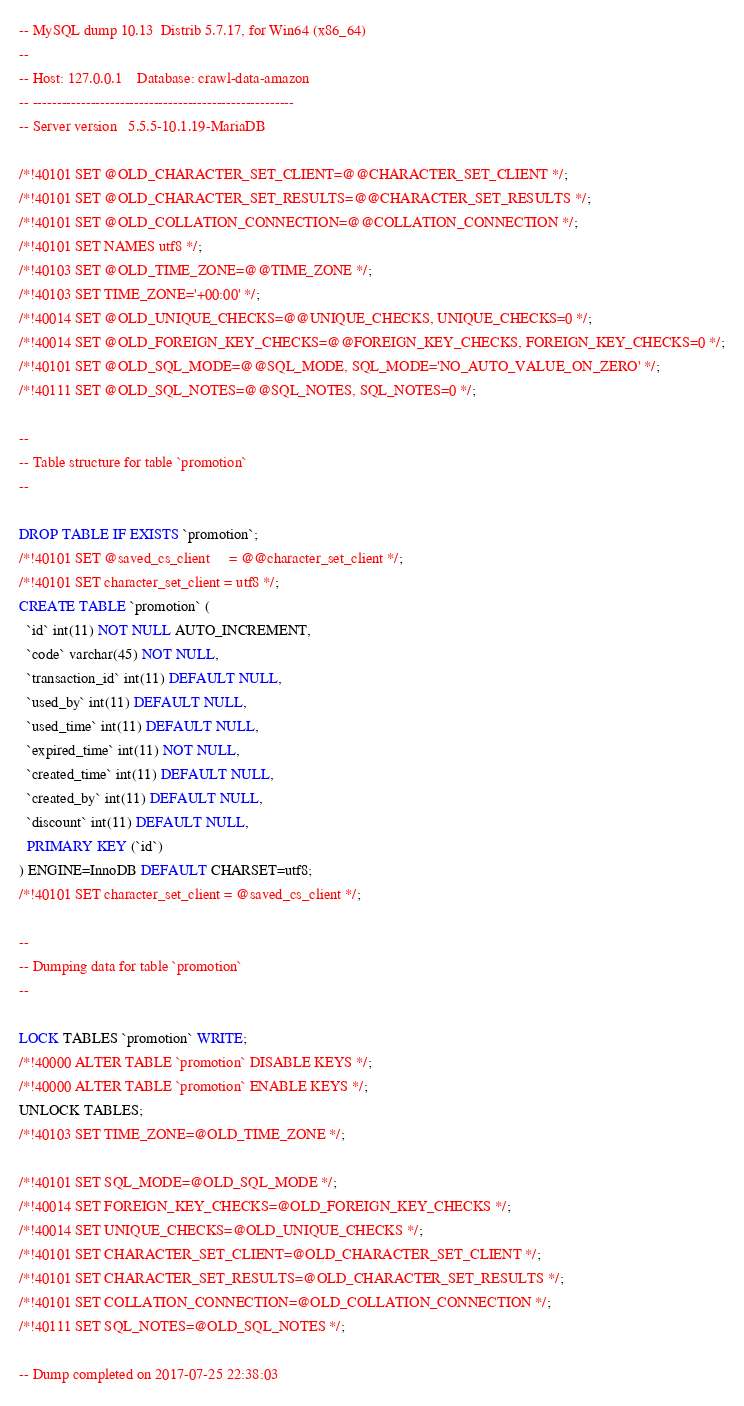Convert code to text. <code><loc_0><loc_0><loc_500><loc_500><_SQL_>-- MySQL dump 10.13  Distrib 5.7.17, for Win64 (x86_64)
--
-- Host: 127.0.0.1    Database: crawl-data-amazon
-- ------------------------------------------------------
-- Server version	5.5.5-10.1.19-MariaDB

/*!40101 SET @OLD_CHARACTER_SET_CLIENT=@@CHARACTER_SET_CLIENT */;
/*!40101 SET @OLD_CHARACTER_SET_RESULTS=@@CHARACTER_SET_RESULTS */;
/*!40101 SET @OLD_COLLATION_CONNECTION=@@COLLATION_CONNECTION */;
/*!40101 SET NAMES utf8 */;
/*!40103 SET @OLD_TIME_ZONE=@@TIME_ZONE */;
/*!40103 SET TIME_ZONE='+00:00' */;
/*!40014 SET @OLD_UNIQUE_CHECKS=@@UNIQUE_CHECKS, UNIQUE_CHECKS=0 */;
/*!40014 SET @OLD_FOREIGN_KEY_CHECKS=@@FOREIGN_KEY_CHECKS, FOREIGN_KEY_CHECKS=0 */;
/*!40101 SET @OLD_SQL_MODE=@@SQL_MODE, SQL_MODE='NO_AUTO_VALUE_ON_ZERO' */;
/*!40111 SET @OLD_SQL_NOTES=@@SQL_NOTES, SQL_NOTES=0 */;

--
-- Table structure for table `promotion`
--

DROP TABLE IF EXISTS `promotion`;
/*!40101 SET @saved_cs_client     = @@character_set_client */;
/*!40101 SET character_set_client = utf8 */;
CREATE TABLE `promotion` (
  `id` int(11) NOT NULL AUTO_INCREMENT,
  `code` varchar(45) NOT NULL,
  `transaction_id` int(11) DEFAULT NULL,
  `used_by` int(11) DEFAULT NULL,
  `used_time` int(11) DEFAULT NULL,
  `expired_time` int(11) NOT NULL,
  `created_time` int(11) DEFAULT NULL,
  `created_by` int(11) DEFAULT NULL,
  `discount` int(11) DEFAULT NULL,
  PRIMARY KEY (`id`)
) ENGINE=InnoDB DEFAULT CHARSET=utf8;
/*!40101 SET character_set_client = @saved_cs_client */;

--
-- Dumping data for table `promotion`
--

LOCK TABLES `promotion` WRITE;
/*!40000 ALTER TABLE `promotion` DISABLE KEYS */;
/*!40000 ALTER TABLE `promotion` ENABLE KEYS */;
UNLOCK TABLES;
/*!40103 SET TIME_ZONE=@OLD_TIME_ZONE */;

/*!40101 SET SQL_MODE=@OLD_SQL_MODE */;
/*!40014 SET FOREIGN_KEY_CHECKS=@OLD_FOREIGN_KEY_CHECKS */;
/*!40014 SET UNIQUE_CHECKS=@OLD_UNIQUE_CHECKS */;
/*!40101 SET CHARACTER_SET_CLIENT=@OLD_CHARACTER_SET_CLIENT */;
/*!40101 SET CHARACTER_SET_RESULTS=@OLD_CHARACTER_SET_RESULTS */;
/*!40101 SET COLLATION_CONNECTION=@OLD_COLLATION_CONNECTION */;
/*!40111 SET SQL_NOTES=@OLD_SQL_NOTES */;

-- Dump completed on 2017-07-25 22:38:03
</code> 